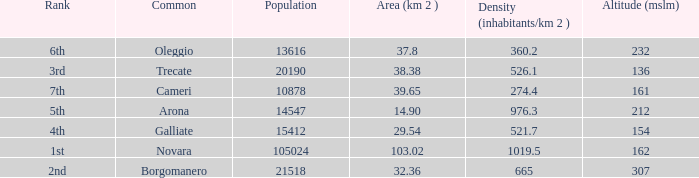Where does the common of Galliate rank in population? 4th. 